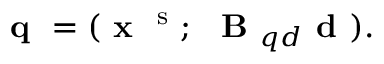<formula> <loc_0><loc_0><loc_500><loc_500>q = ( x ^ { s } ; B _ { q d } d ) .</formula> 